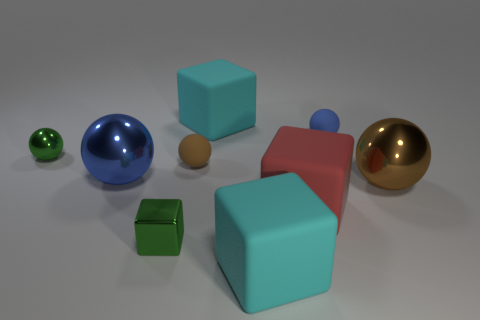What is the color of the small block that is made of the same material as the large blue thing?
Provide a short and direct response. Green. Are there fewer big cyan rubber blocks that are in front of the large brown metallic sphere than tiny green spheres?
Your answer should be compact. No. There is a tiny brown thing that is made of the same material as the big red cube; what is its shape?
Your answer should be compact. Sphere. What number of metallic objects are big objects or large brown balls?
Your answer should be very brief. 2. Are there an equal number of large blue metallic spheres in front of the metallic block and big blue metallic objects?
Provide a succinct answer. No. Do the small shiny object that is in front of the red cube and the tiny metallic ball have the same color?
Your answer should be very brief. Yes. There is a ball that is both behind the large blue object and on the right side of the small brown matte sphere; what is its material?
Keep it short and to the point. Rubber. There is a green metal object in front of the blue metallic thing; are there any small green shiny blocks in front of it?
Ensure brevity in your answer.  No. Are the small green cube and the tiny brown thing made of the same material?
Provide a succinct answer. No. What is the shape of the thing that is both on the right side of the large red block and behind the large brown metallic thing?
Offer a terse response. Sphere. 